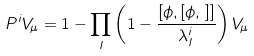Convert formula to latex. <formula><loc_0><loc_0><loc_500><loc_500>P ^ { i } V _ { \mu } = 1 - \prod _ { I } \left ( 1 - \frac { [ \phi , [ \phi , \, ] ] } { \lambda _ { I } ^ { i } } \right ) V _ { \mu }</formula> 